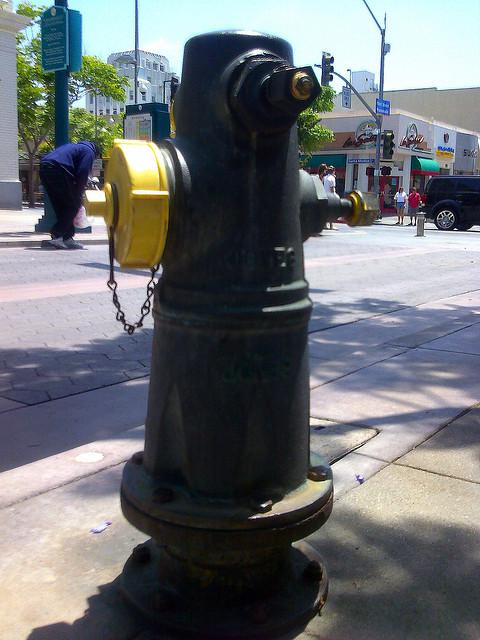What is inside the green and yellow object on the sidewalk?

Choices:
A) mud
B) water
C) beer
D) candy water 